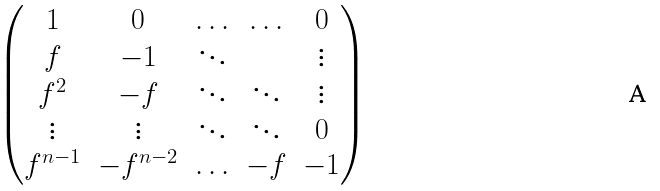<formula> <loc_0><loc_0><loc_500><loc_500>\begin{pmatrix} 1 & 0 & \hdots & \hdots & 0 \\ f & - 1 & \ddots & & \vdots \\ f ^ { 2 } & - f & \ddots & \ddots & \vdots \\ \vdots & \vdots & \ddots & \ddots & 0 \\ f ^ { n - 1 } & - f ^ { n - 2 } & \hdots & - f & - 1 \end{pmatrix}</formula> 